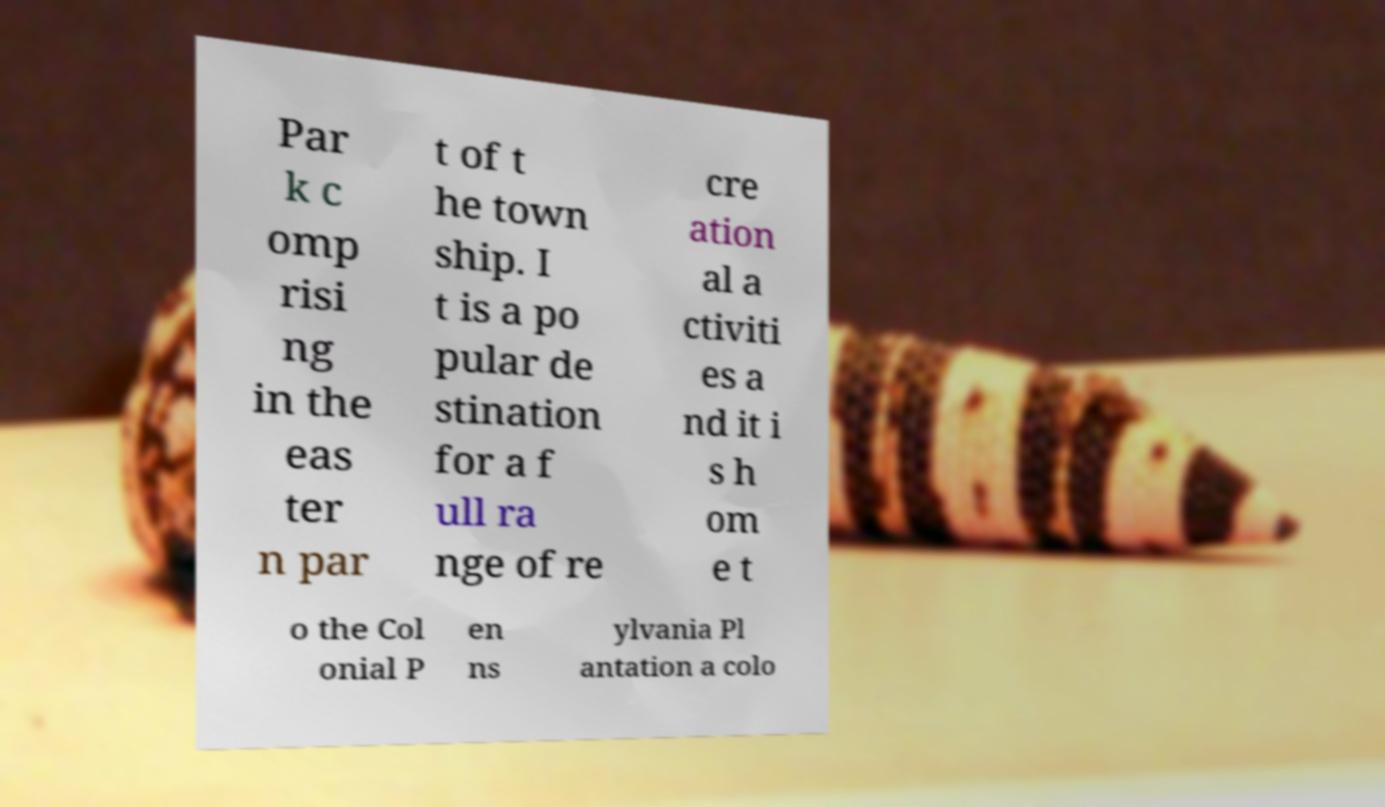Can you accurately transcribe the text from the provided image for me? Par k c omp risi ng in the eas ter n par t of t he town ship. I t is a po pular de stination for a f ull ra nge of re cre ation al a ctiviti es a nd it i s h om e t o the Col onial P en ns ylvania Pl antation a colo 